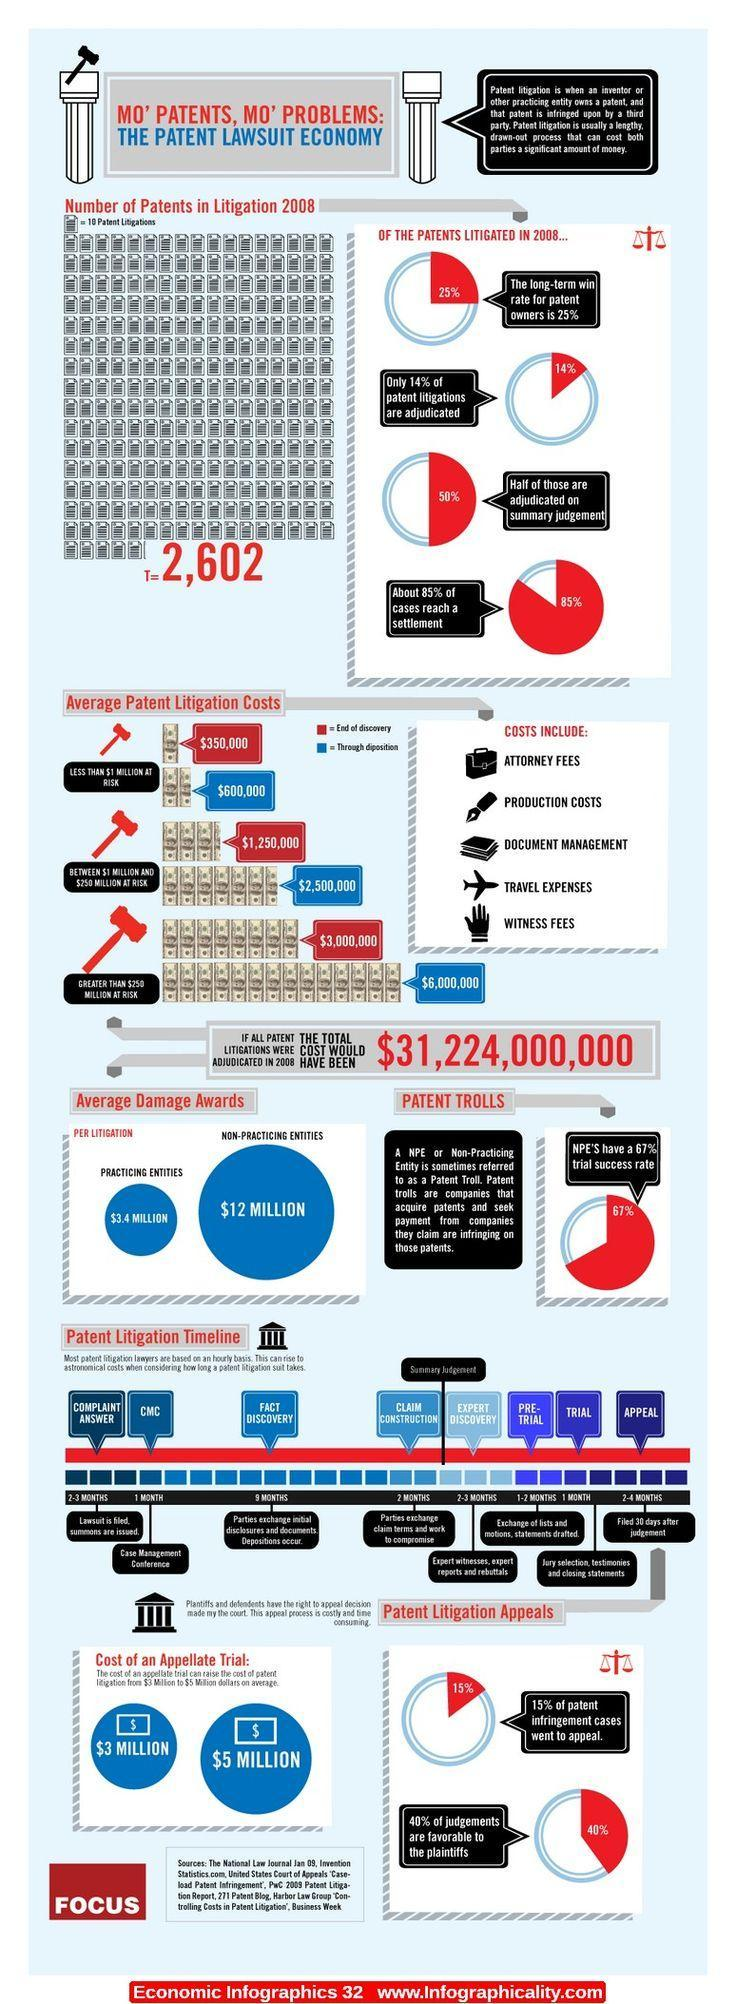what percent of cases do not reach a settlement
Answer the question with a short phrase. 15 what is the % failure trail of NPE'S 33 what is the  difference between the average damage award for non-practicing and practicing entities per litigation in million 8.6 what is the average damage award for non-practicing entities per litigation $12 million how many patents in litigation in 2008 2,602 what is the average damage award for practicing entities per litigation $3.4 million 